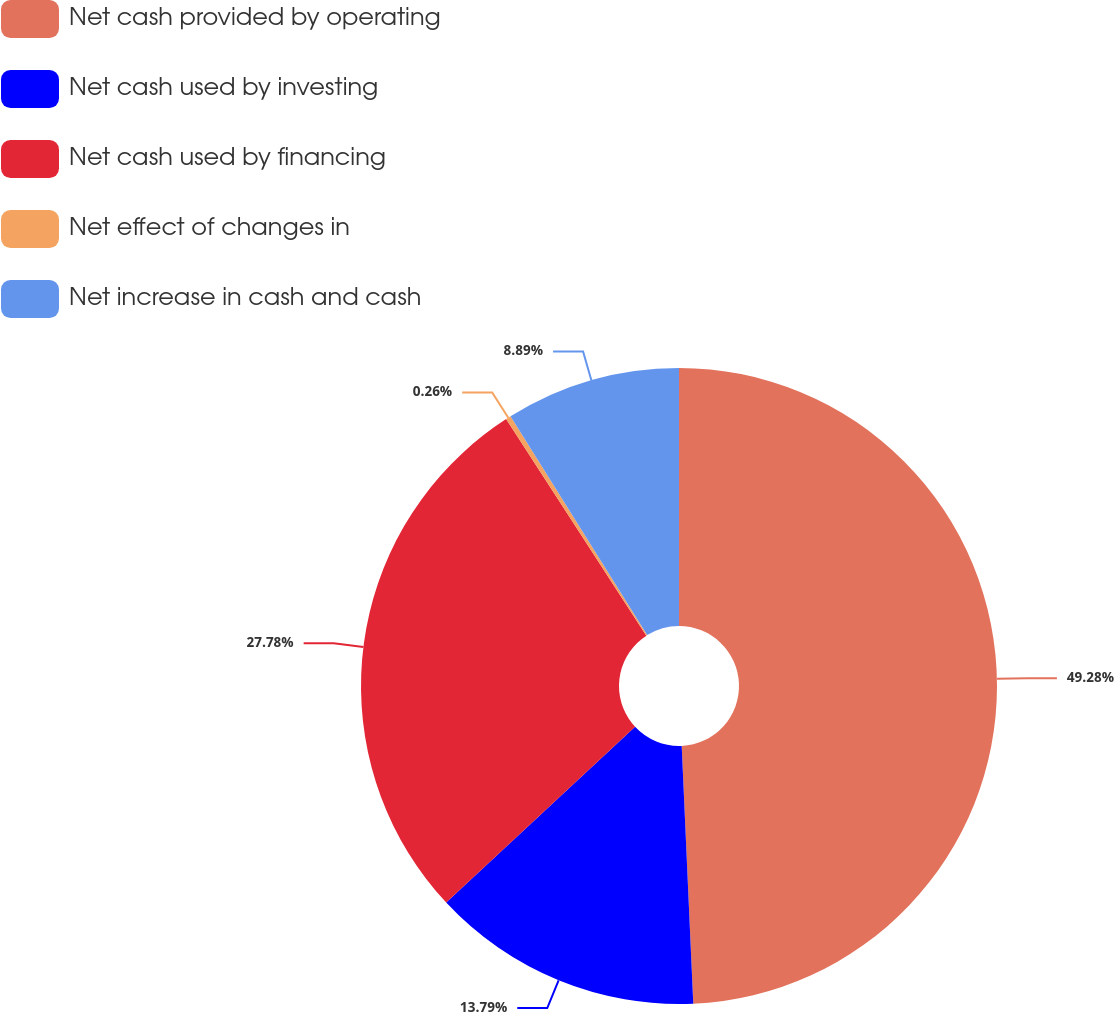Convert chart to OTSL. <chart><loc_0><loc_0><loc_500><loc_500><pie_chart><fcel>Net cash provided by operating<fcel>Net cash used by investing<fcel>Net cash used by financing<fcel>Net effect of changes in<fcel>Net increase in cash and cash<nl><fcel>49.29%<fcel>13.79%<fcel>27.78%<fcel>0.26%<fcel>8.89%<nl></chart> 